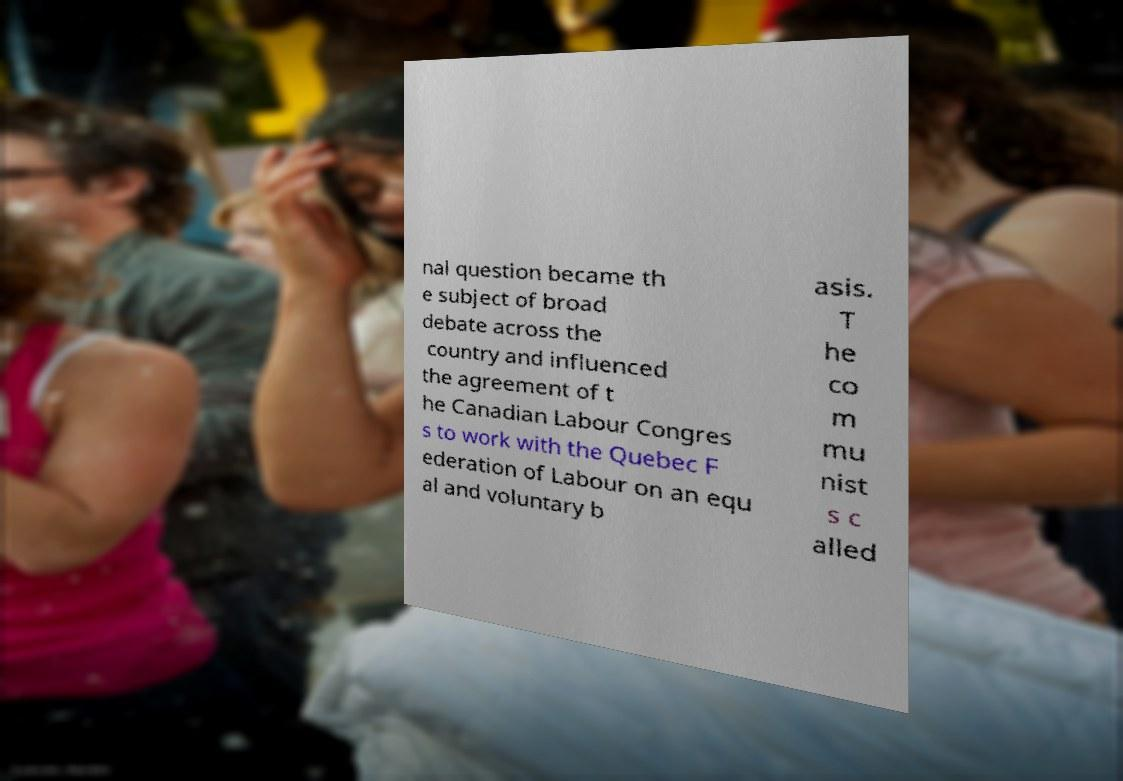Could you assist in decoding the text presented in this image and type it out clearly? nal question became th e subject of broad debate across the country and influenced the agreement of t he Canadian Labour Congres s to work with the Quebec F ederation of Labour on an equ al and voluntary b asis. T he co m mu nist s c alled 